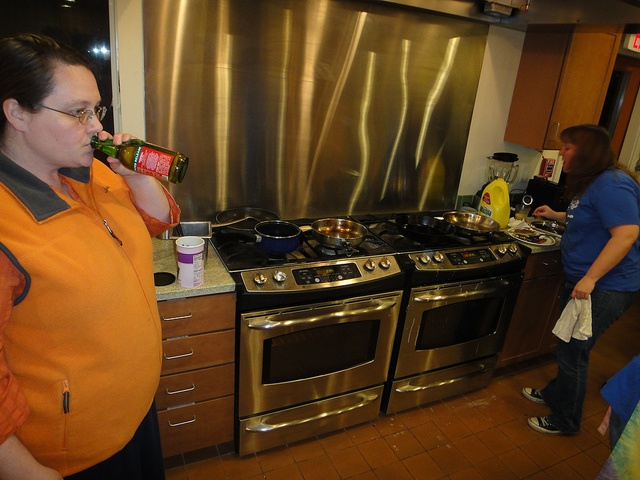Describe the objects in this image and their specific colors. I can see people in black, red, orange, and gray tones, oven in black, maroon, and olive tones, oven in black, maroon, and olive tones, people in black, navy, brown, and maroon tones, and people in black, navy, olive, and darkgreen tones in this image. 